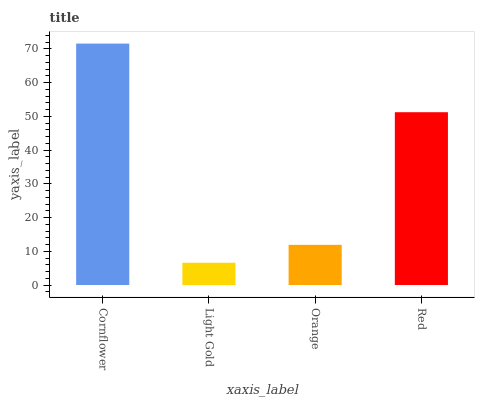Is Light Gold the minimum?
Answer yes or no. Yes. Is Cornflower the maximum?
Answer yes or no. Yes. Is Orange the minimum?
Answer yes or no. No. Is Orange the maximum?
Answer yes or no. No. Is Orange greater than Light Gold?
Answer yes or no. Yes. Is Light Gold less than Orange?
Answer yes or no. Yes. Is Light Gold greater than Orange?
Answer yes or no. No. Is Orange less than Light Gold?
Answer yes or no. No. Is Red the high median?
Answer yes or no. Yes. Is Orange the low median?
Answer yes or no. Yes. Is Cornflower the high median?
Answer yes or no. No. Is Red the low median?
Answer yes or no. No. 